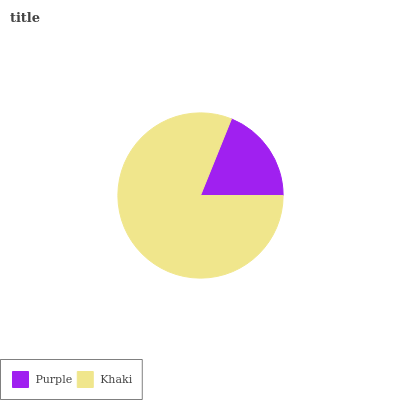Is Purple the minimum?
Answer yes or no. Yes. Is Khaki the maximum?
Answer yes or no. Yes. Is Khaki the minimum?
Answer yes or no. No. Is Khaki greater than Purple?
Answer yes or no. Yes. Is Purple less than Khaki?
Answer yes or no. Yes. Is Purple greater than Khaki?
Answer yes or no. No. Is Khaki less than Purple?
Answer yes or no. No. Is Khaki the high median?
Answer yes or no. Yes. Is Purple the low median?
Answer yes or no. Yes. Is Purple the high median?
Answer yes or no. No. Is Khaki the low median?
Answer yes or no. No. 